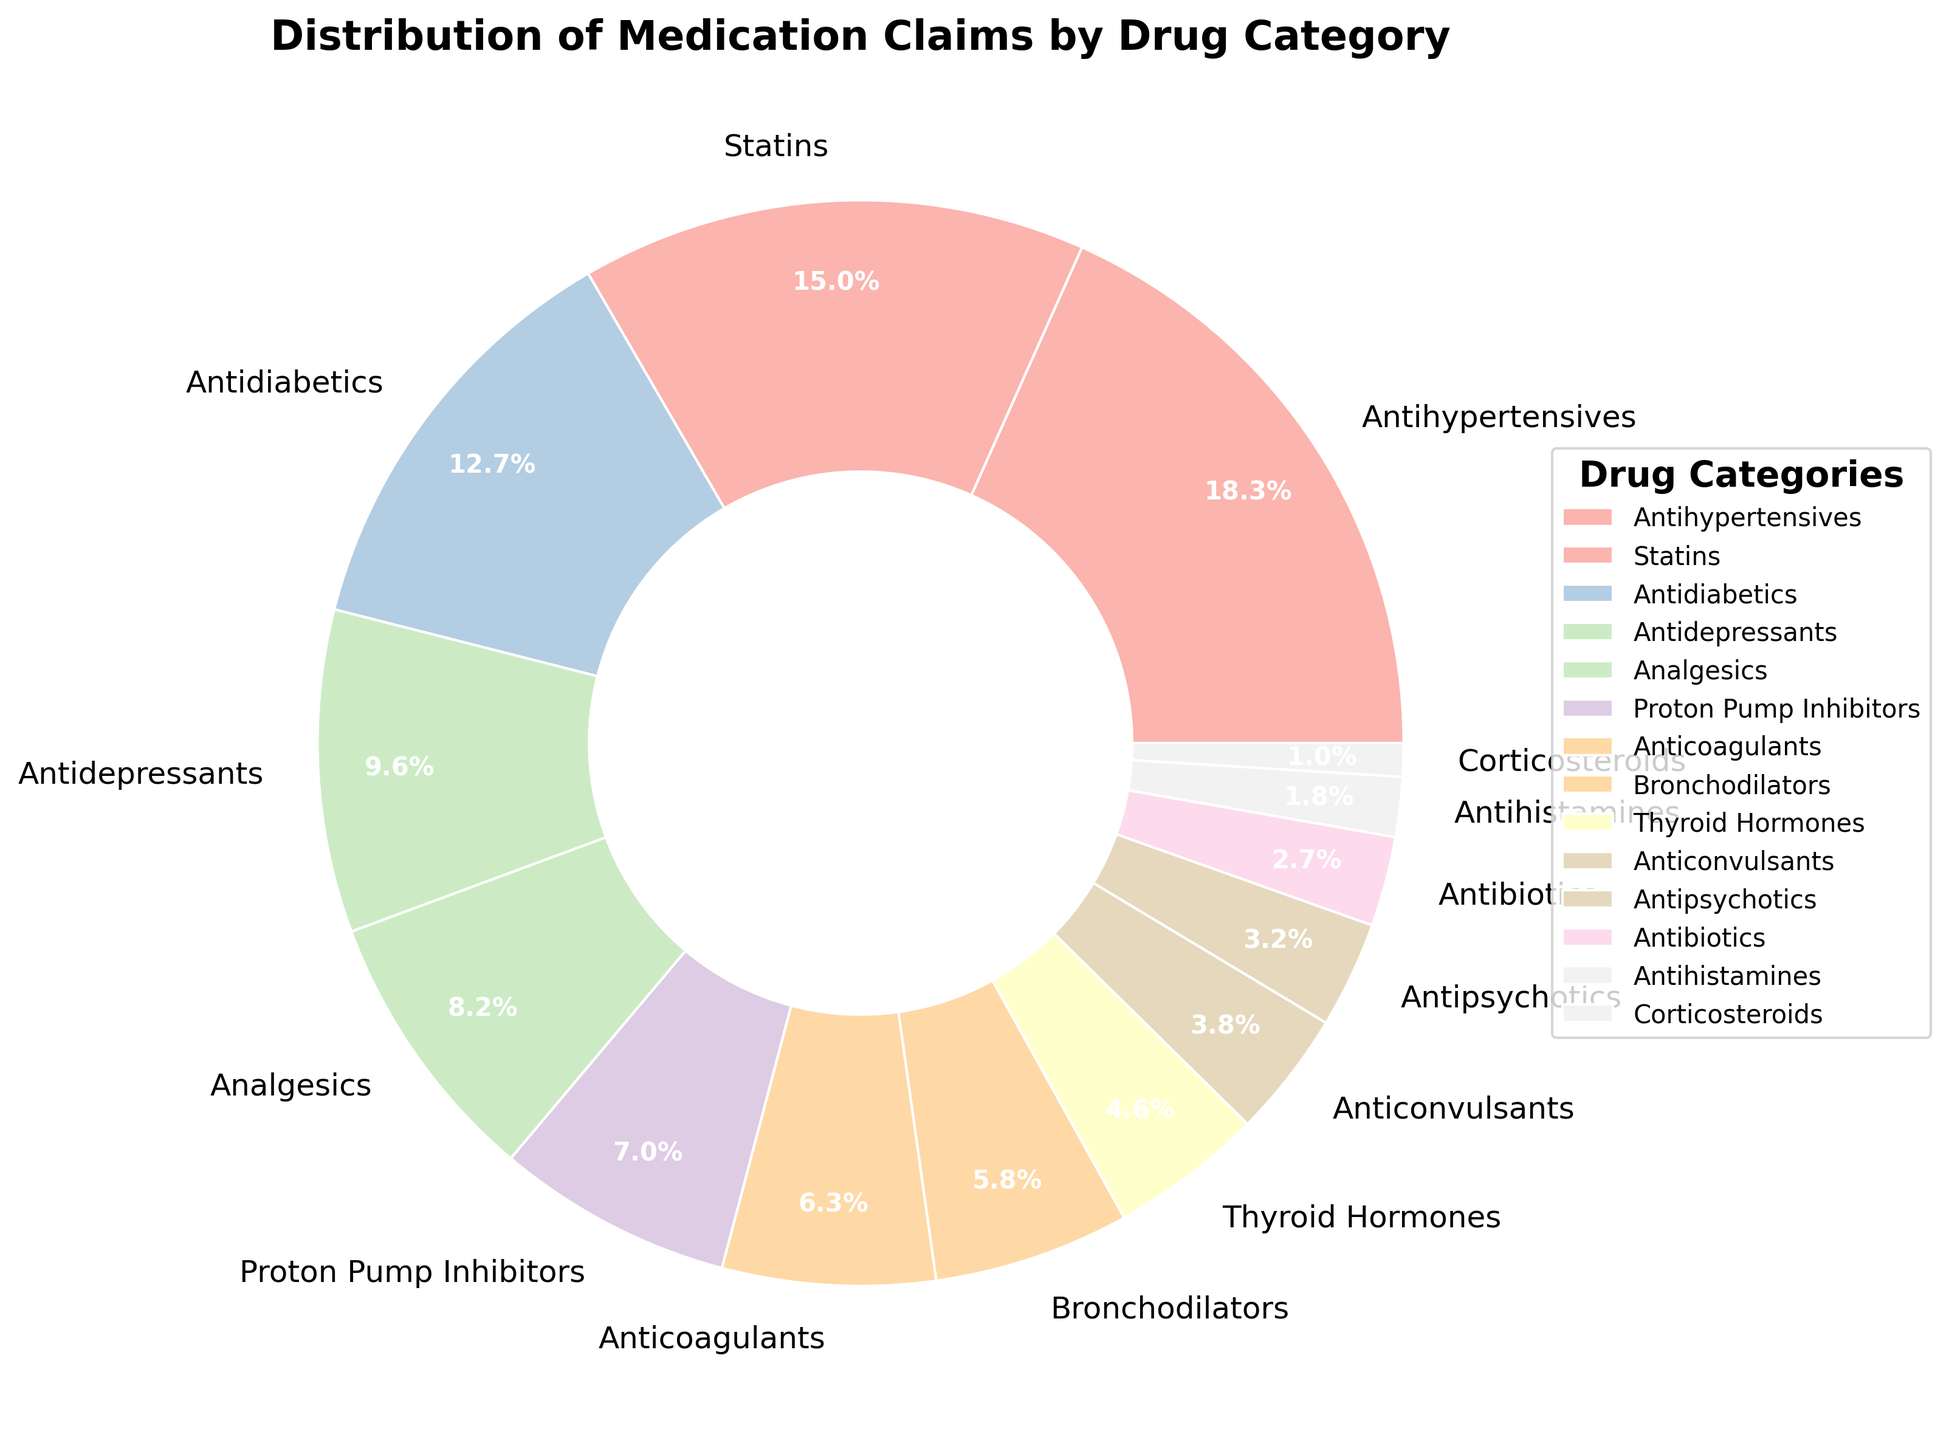What is the largest drug category by claims percentage? The largest segment in the pie chart, taking up the most space and labeled as such, is Antihypertensives with 18.5% of claims.
Answer: Antihypertensives Which drug category accounts for 15.2% of the claims? By locating and reading the label directly on the pie chart, the drug category that accounts for 15.2% of the claims is Statins.
Answer: Statins How many drug categories are there in total? By counting the number of labeled segments on the pie chart, we can see there are 14 drug categories represented.
Answer: 14 What is the combined percentage of Antidepressants and Analgesics claims? By adding the percentages of Antidepressants (9.7%) and Analgesics (8.3%), we get 9.7 + 8.3 = 18%.
Answer: 18% Which drug category has the smallest percentage of claims? The smallest segment in the pie chart, taking up the least space and labeled as such, is Corticosteroids with 1.0% of claims.
Answer: Corticosteroids Is the percentage of claims for Anticoagulants greater than that for Bronchodilators? Comparing the labeled percentages directly, Anticoagulants have 6.4% and Bronchodilators have 5.9%. Since 6.4% is greater than 5.9%, the answer is yes.
Answer: Yes What is the percentage difference between Proton Pump Inhibitors and Thyroid Hormones? Subtracting the percentage of Thyroid Hormones (4.6%) from Proton Pump Inhibitors (7.1%) gives 7.1 - 4.6 = 2.5%.
Answer: 2.5% Which drug categories combined account for more than 30% of the claims? Adding up smaller groups' percentages until we exceed 30%, we consider Antihypertensives (18.5%), Statins (15.2%), and Antidiabetics (12.8%). The first two already sum to 33.7%, which is more than 30%.
Answer: Antihypertensives and Statins Are there more claims for Antibiotics or Anticonvulsants? Comparing the labeled percentages directly, Antibiotics have 2.7% and Anticonvulsants have 3.8%. Since 3.8% is greater than 2.7%, more claims are for Anticonvulsants.
Answer: Anticonvulsants What is the average percentage of claims for the drug categories listed? Adding up all percentages and dividing by the number of categories: (18.5 + 15.2 + 12.8 + 9.7 + 8.3 + 7.1 + 6.4 + 5.9 + 4.6 + 3.8 + 3.2 + 2.7 + 1.8 + 1.0)/14. Total is 100.0, so 100.0/14 ≈ 7.14%.
Answer: 7.14% 